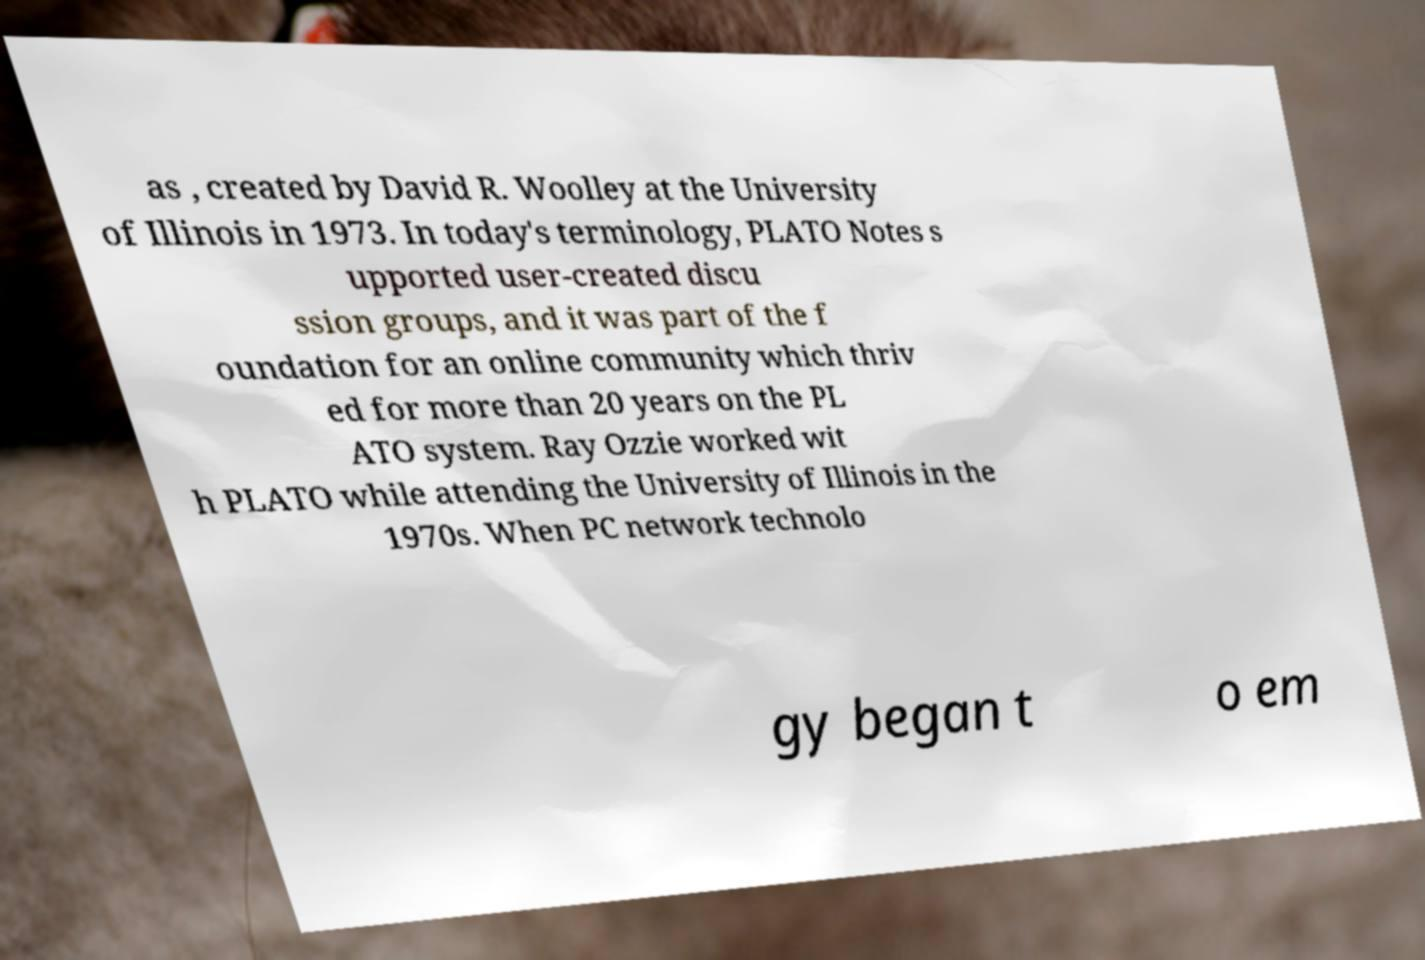Can you read and provide the text displayed in the image?This photo seems to have some interesting text. Can you extract and type it out for me? as , created by David R. Woolley at the University of Illinois in 1973. In today's terminology, PLATO Notes s upported user-created discu ssion groups, and it was part of the f oundation for an online community which thriv ed for more than 20 years on the PL ATO system. Ray Ozzie worked wit h PLATO while attending the University of Illinois in the 1970s. When PC network technolo gy began t o em 